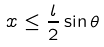<formula> <loc_0><loc_0><loc_500><loc_500>x \leq \frac { l } { 2 } \sin \theta</formula> 